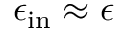Convert formula to latex. <formula><loc_0><loc_0><loc_500><loc_500>\epsilon _ { i n } \approx \epsilon</formula> 